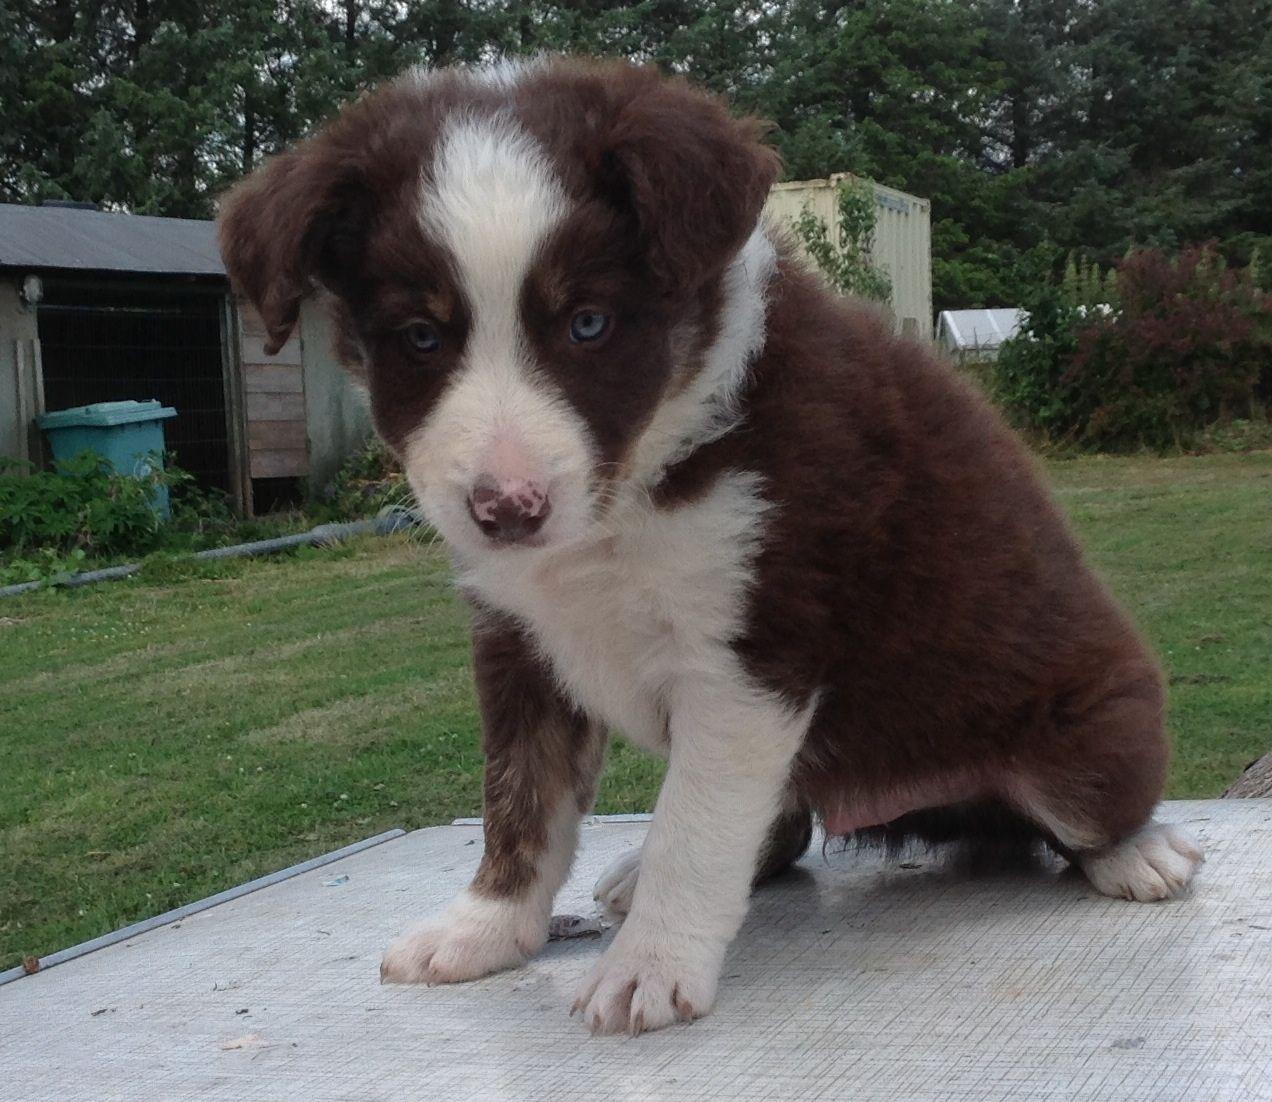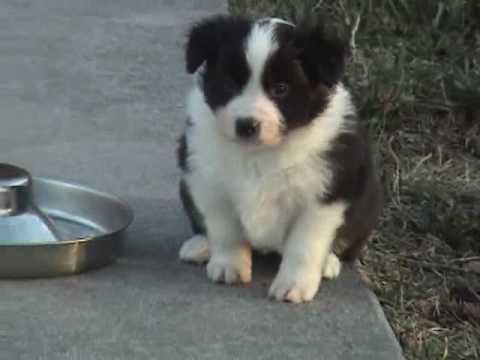The first image is the image on the left, the second image is the image on the right. For the images displayed, is the sentence "All of the dogs are sitting." factually correct? Answer yes or no. Yes. The first image is the image on the left, the second image is the image on the right. Considering the images on both sides, is "One of the pups is on the sidewalk." valid? Answer yes or no. Yes. 